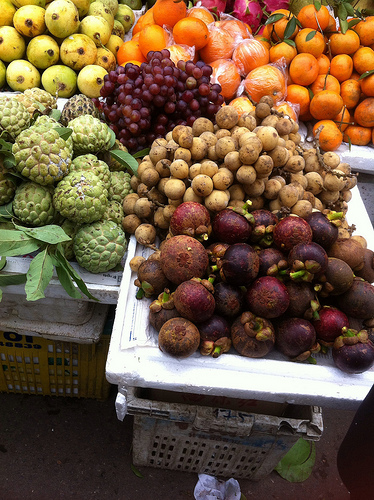<image>
Can you confirm if the orange is on the grapes? No. The orange is not positioned on the grapes. They may be near each other, but the orange is not supported by or resting on top of the grapes. Is there a potatoes on the oranges? No. The potatoes is not positioned on the oranges. They may be near each other, but the potatoes is not supported by or resting on top of the oranges. 